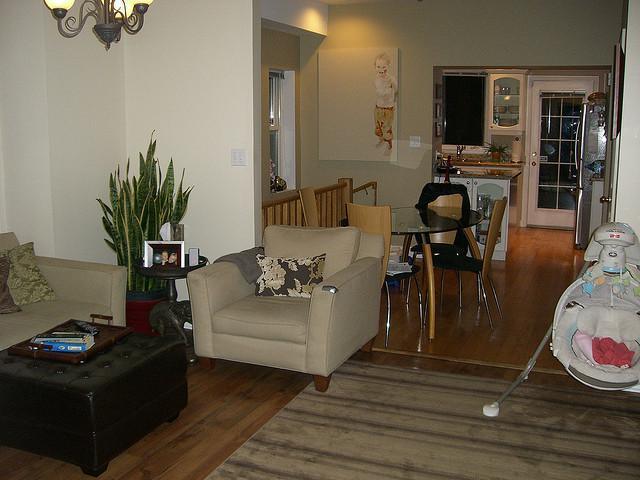How many door knobs are visible?
Give a very brief answer. 1. How many chairs are in the photo?
Give a very brief answer. 3. How many refrigerators can be seen?
Give a very brief answer. 1. 